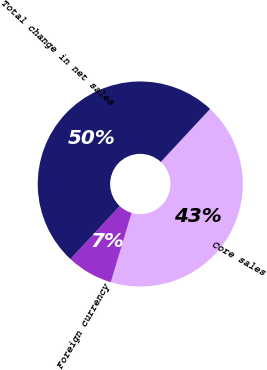<chart> <loc_0><loc_0><loc_500><loc_500><pie_chart><fcel>Core sales<fcel>Foreign currency<fcel>Total change in net sales<nl><fcel>42.71%<fcel>7.29%<fcel>50.0%<nl></chart> 